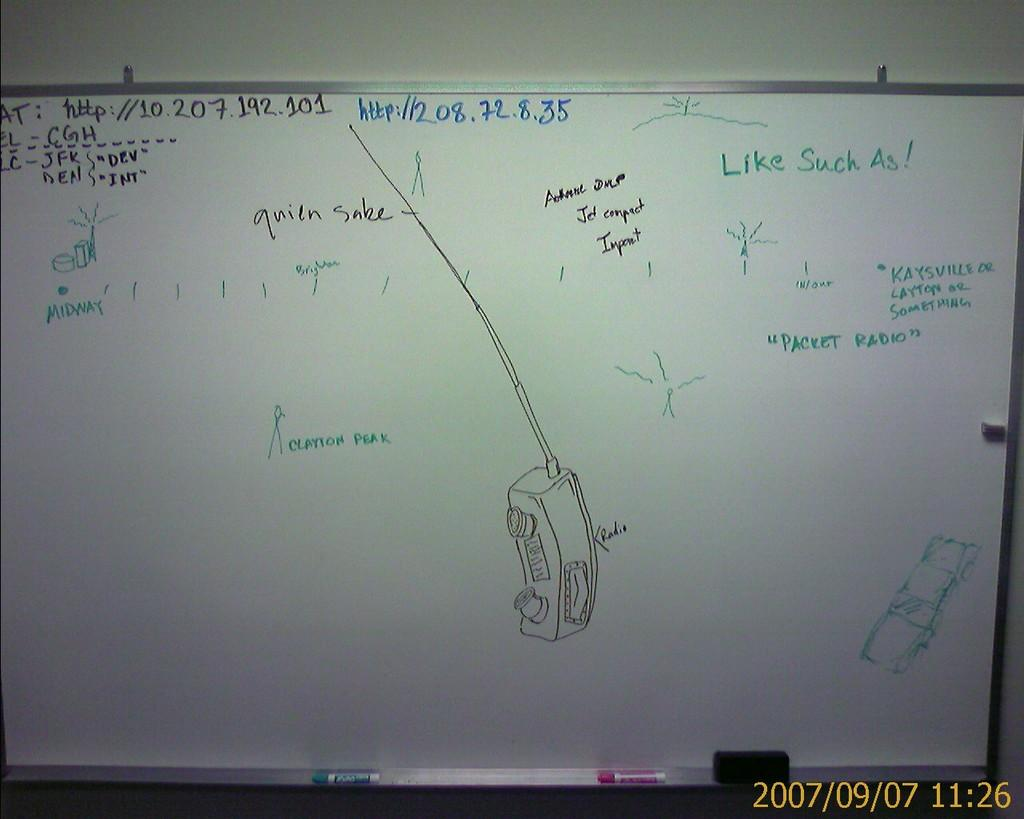What is on the wall in the image? There is a board on a wall in the image. What is written or displayed on the board? There is text on the board. What objects are visible that might be used to write or draw on the board? There are markers visible in the image. Where is the father standing on the stage in the image? There is no father or stage present in the image; it only features a board with text and markers. What type of butter is being used to write on the board in the image? There is no butter present in the image; the markers are used to write or draw on the board. 